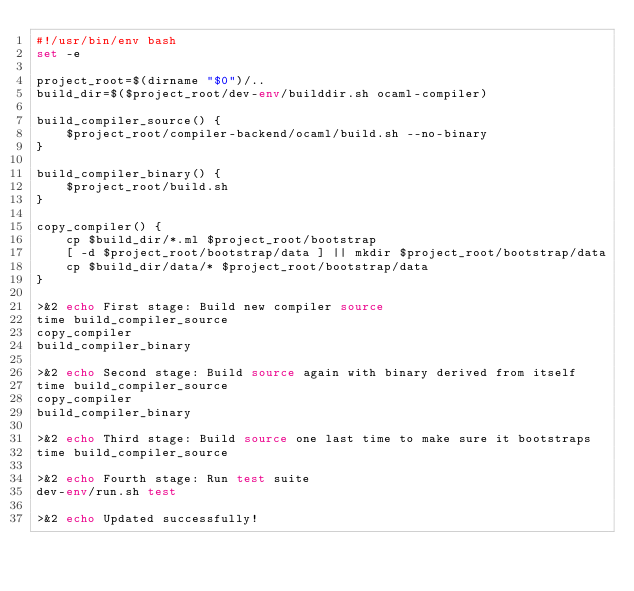Convert code to text. <code><loc_0><loc_0><loc_500><loc_500><_Bash_>#!/usr/bin/env bash
set -e

project_root=$(dirname "$0")/..
build_dir=$($project_root/dev-env/builddir.sh ocaml-compiler)

build_compiler_source() {
    $project_root/compiler-backend/ocaml/build.sh --no-binary
}

build_compiler_binary() {
    $project_root/build.sh
}

copy_compiler() {
    cp $build_dir/*.ml $project_root/bootstrap
    [ -d $project_root/bootstrap/data ] || mkdir $project_root/bootstrap/data
    cp $build_dir/data/* $project_root/bootstrap/data
}

>&2 echo First stage: Build new compiler source
time build_compiler_source
copy_compiler
build_compiler_binary

>&2 echo Second stage: Build source again with binary derived from itself
time build_compiler_source
copy_compiler
build_compiler_binary

>&2 echo Third stage: Build source one last time to make sure it bootstraps
time build_compiler_source

>&2 echo Fourth stage: Run test suite
dev-env/run.sh test

>&2 echo Updated successfully!
</code> 